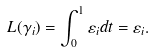<formula> <loc_0><loc_0><loc_500><loc_500>L ( \gamma _ { i } ) = \int _ { 0 } ^ { 1 } \varepsilon _ { i } d t = \varepsilon _ { i } .</formula> 